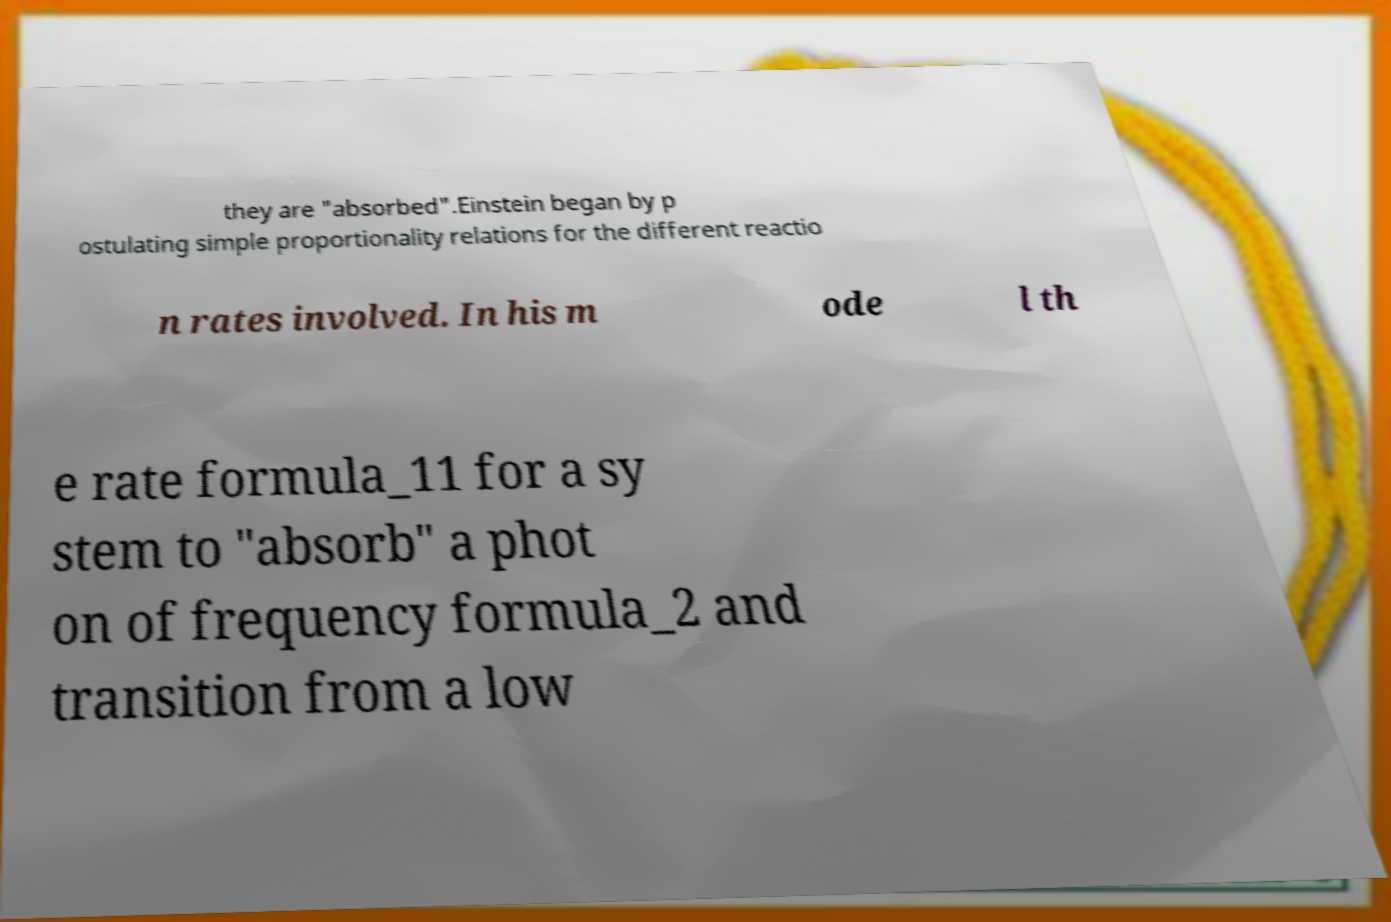Could you assist in decoding the text presented in this image and type it out clearly? they are "absorbed".Einstein began by p ostulating simple proportionality relations for the different reactio n rates involved. In his m ode l th e rate formula_11 for a sy stem to "absorb" a phot on of frequency formula_2 and transition from a low 